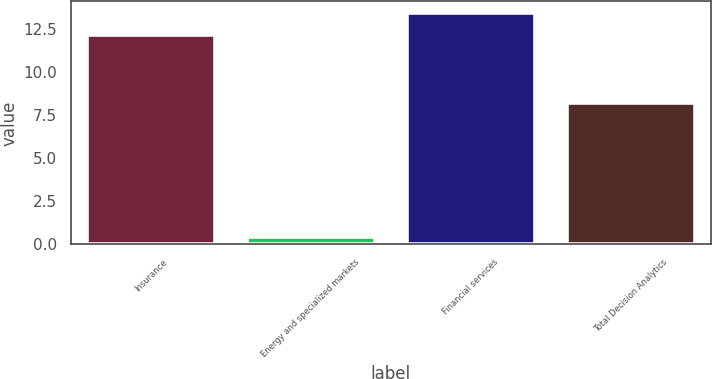<chart> <loc_0><loc_0><loc_500><loc_500><bar_chart><fcel>Insurance<fcel>Energy and specialized markets<fcel>Financial services<fcel>Total Decision Analytics<nl><fcel>12.1<fcel>0.4<fcel>13.4<fcel>8.2<nl></chart> 